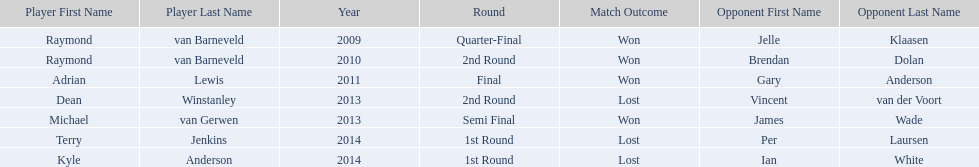Who were the players in 2014? Terry Jenkins, Kyle Anderson. Did they win or lose? Per Laursen. 